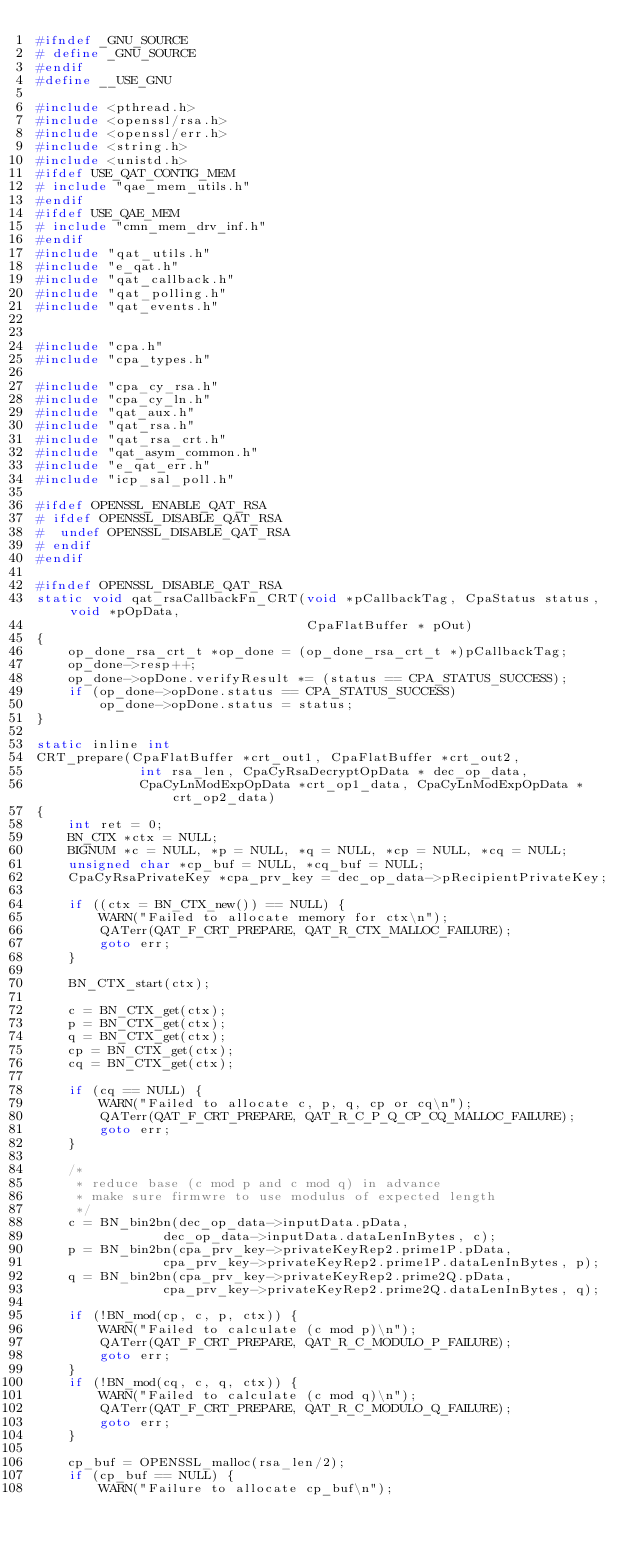Convert code to text. <code><loc_0><loc_0><loc_500><loc_500><_C_>#ifndef _GNU_SOURCE
# define _GNU_SOURCE
#endif
#define __USE_GNU

#include <pthread.h>
#include <openssl/rsa.h>
#include <openssl/err.h>
#include <string.h>
#include <unistd.h>
#ifdef USE_QAT_CONTIG_MEM
# include "qae_mem_utils.h"
#endif
#ifdef USE_QAE_MEM
# include "cmn_mem_drv_inf.h"
#endif
#include "qat_utils.h"
#include "e_qat.h"
#include "qat_callback.h"
#include "qat_polling.h"
#include "qat_events.h"


#include "cpa.h"
#include "cpa_types.h"

#include "cpa_cy_rsa.h"
#include "cpa_cy_ln.h"
#include "qat_aux.h"
#include "qat_rsa.h"
#include "qat_rsa_crt.h"
#include "qat_asym_common.h"
#include "e_qat_err.h"
#include "icp_sal_poll.h"

#ifdef OPENSSL_ENABLE_QAT_RSA
# ifdef OPENSSL_DISABLE_QAT_RSA
#  undef OPENSSL_DISABLE_QAT_RSA
# endif
#endif

#ifndef OPENSSL_DISABLE_QAT_RSA
static void qat_rsaCallbackFn_CRT(void *pCallbackTag, CpaStatus status, void *pOpData,
                                  CpaFlatBuffer * pOut)
{
    op_done_rsa_crt_t *op_done = (op_done_rsa_crt_t *)pCallbackTag;
    op_done->resp++;
    op_done->opDone.verifyResult *= (status == CPA_STATUS_SUCCESS);
    if (op_done->opDone.status == CPA_STATUS_SUCCESS)
        op_done->opDone.status = status;
}

static inline int
CRT_prepare(CpaFlatBuffer *crt_out1, CpaFlatBuffer *crt_out2,
             int rsa_len, CpaCyRsaDecryptOpData * dec_op_data,
             CpaCyLnModExpOpData *crt_op1_data, CpaCyLnModExpOpData *crt_op2_data)
{
    int ret = 0;
    BN_CTX *ctx = NULL;
    BIGNUM *c = NULL, *p = NULL, *q = NULL, *cp = NULL, *cq = NULL;
    unsigned char *cp_buf = NULL, *cq_buf = NULL;
    CpaCyRsaPrivateKey *cpa_prv_key = dec_op_data->pRecipientPrivateKey;

    if ((ctx = BN_CTX_new()) == NULL) {
        WARN("Failed to allocate memory for ctx\n");
        QATerr(QAT_F_CRT_PREPARE, QAT_R_CTX_MALLOC_FAILURE);
        goto err;
    }

    BN_CTX_start(ctx);

    c = BN_CTX_get(ctx);
    p = BN_CTX_get(ctx);
    q = BN_CTX_get(ctx);
    cp = BN_CTX_get(ctx);
    cq = BN_CTX_get(ctx);

    if (cq == NULL) {
        WARN("Failed to allocate c, p, q, cp or cq\n");
        QATerr(QAT_F_CRT_PREPARE, QAT_R_C_P_Q_CP_CQ_MALLOC_FAILURE);
        goto err;
    }

    /*
     * reduce base (c mod p and c mod q) in advance
     * make sure firmwre to use modulus of expected length
     */
    c = BN_bin2bn(dec_op_data->inputData.pData,
                dec_op_data->inputData.dataLenInBytes, c);
    p = BN_bin2bn(cpa_prv_key->privateKeyRep2.prime1P.pData,
                cpa_prv_key->privateKeyRep2.prime1P.dataLenInBytes, p);
    q = BN_bin2bn(cpa_prv_key->privateKeyRep2.prime2Q.pData,
                cpa_prv_key->privateKeyRep2.prime2Q.dataLenInBytes, q);

    if (!BN_mod(cp, c, p, ctx)) {
        WARN("Failed to calculate (c mod p)\n");
        QATerr(QAT_F_CRT_PREPARE, QAT_R_C_MODULO_P_FAILURE);
        goto err;
    }
    if (!BN_mod(cq, c, q, ctx)) {
        WARN("Failed to calculate (c mod q)\n");
        QATerr(QAT_F_CRT_PREPARE, QAT_R_C_MODULO_Q_FAILURE);
        goto err;
    }

    cp_buf = OPENSSL_malloc(rsa_len/2);
    if (cp_buf == NULL) {
        WARN("Failure to allocate cp_buf\n");</code> 